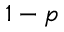<formula> <loc_0><loc_0><loc_500><loc_500>1 - p</formula> 